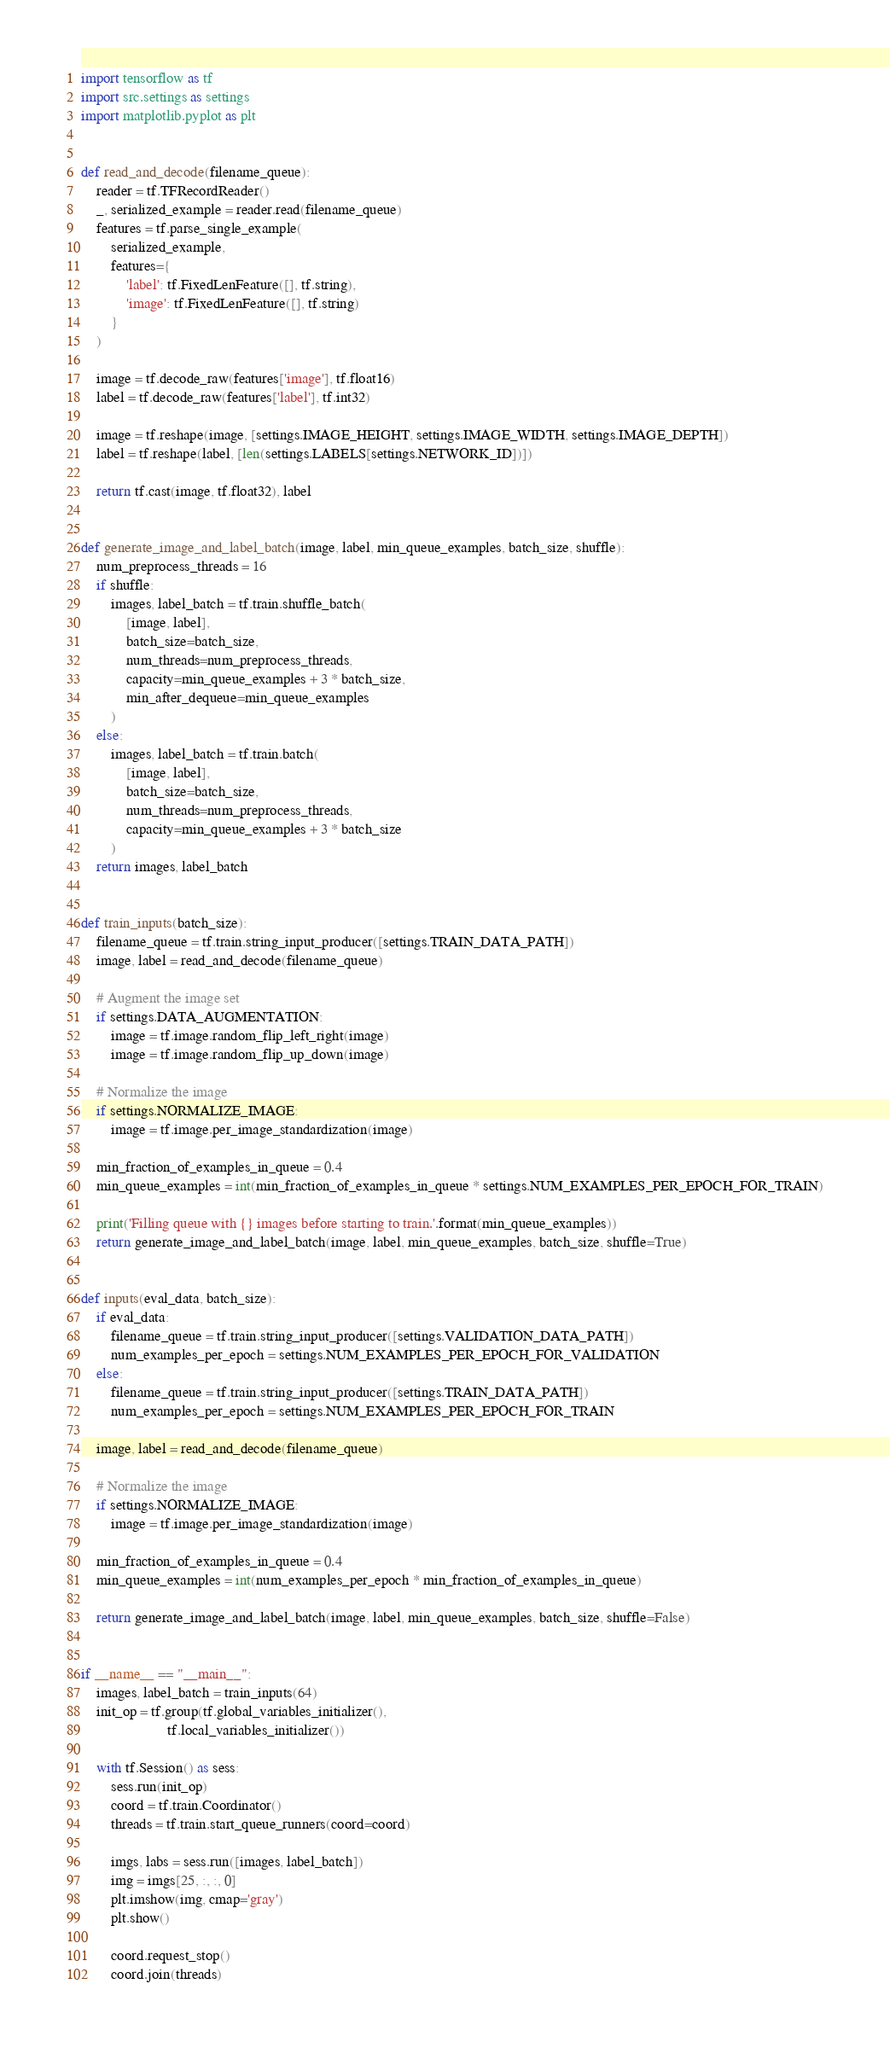Convert code to text. <code><loc_0><loc_0><loc_500><loc_500><_Python_>import tensorflow as tf
import src.settings as settings
import matplotlib.pyplot as plt


def read_and_decode(filename_queue):
    reader = tf.TFRecordReader()
    _, serialized_example = reader.read(filename_queue)
    features = tf.parse_single_example(
        serialized_example,
        features={
            'label': tf.FixedLenFeature([], tf.string),
            'image': tf.FixedLenFeature([], tf.string)
        }
    )

    image = tf.decode_raw(features['image'], tf.float16)
    label = tf.decode_raw(features['label'], tf.int32)

    image = tf.reshape(image, [settings.IMAGE_HEIGHT, settings.IMAGE_WIDTH, settings.IMAGE_DEPTH])
    label = tf.reshape(label, [len(settings.LABELS[settings.NETWORK_ID])])

    return tf.cast(image, tf.float32), label


def generate_image_and_label_batch(image, label, min_queue_examples, batch_size, shuffle):
    num_preprocess_threads = 16
    if shuffle:
        images, label_batch = tf.train.shuffle_batch(
            [image, label],
            batch_size=batch_size,
            num_threads=num_preprocess_threads,
            capacity=min_queue_examples + 3 * batch_size,
            min_after_dequeue=min_queue_examples
        )
    else:
        images, label_batch = tf.train.batch(
            [image, label],
            batch_size=batch_size,
            num_threads=num_preprocess_threads,
            capacity=min_queue_examples + 3 * batch_size
        )
    return images, label_batch


def train_inputs(batch_size):
    filename_queue = tf.train.string_input_producer([settings.TRAIN_DATA_PATH])
    image, label = read_and_decode(filename_queue)

    # Augment the image set
    if settings.DATA_AUGMENTATION:
        image = tf.image.random_flip_left_right(image)
        image = tf.image.random_flip_up_down(image)

    # Normalize the image
    if settings.NORMALIZE_IMAGE:
        image = tf.image.per_image_standardization(image)

    min_fraction_of_examples_in_queue = 0.4
    min_queue_examples = int(min_fraction_of_examples_in_queue * settings.NUM_EXAMPLES_PER_EPOCH_FOR_TRAIN)

    print('Filling queue with {} images before starting to train.'.format(min_queue_examples))
    return generate_image_and_label_batch(image, label, min_queue_examples, batch_size, shuffle=True)


def inputs(eval_data, batch_size):
    if eval_data:
        filename_queue = tf.train.string_input_producer([settings.VALIDATION_DATA_PATH])
        num_examples_per_epoch = settings.NUM_EXAMPLES_PER_EPOCH_FOR_VALIDATION
    else:
        filename_queue = tf.train.string_input_producer([settings.TRAIN_DATA_PATH])
        num_examples_per_epoch = settings.NUM_EXAMPLES_PER_EPOCH_FOR_TRAIN

    image, label = read_and_decode(filename_queue)

    # Normalize the image
    if settings.NORMALIZE_IMAGE:
        image = tf.image.per_image_standardization(image)

    min_fraction_of_examples_in_queue = 0.4
    min_queue_examples = int(num_examples_per_epoch * min_fraction_of_examples_in_queue)

    return generate_image_and_label_batch(image, label, min_queue_examples, batch_size, shuffle=False)


if __name__ == "__main__":
    images, label_batch = train_inputs(64)
    init_op = tf.group(tf.global_variables_initializer(),
                       tf.local_variables_initializer())

    with tf.Session() as sess:
        sess.run(init_op)
        coord = tf.train.Coordinator()
        threads = tf.train.start_queue_runners(coord=coord)

        imgs, labs = sess.run([images, label_batch])
        img = imgs[25, :, :, 0]
        plt.imshow(img, cmap='gray')
        plt.show()

        coord.request_stop()
        coord.join(threads)
</code> 